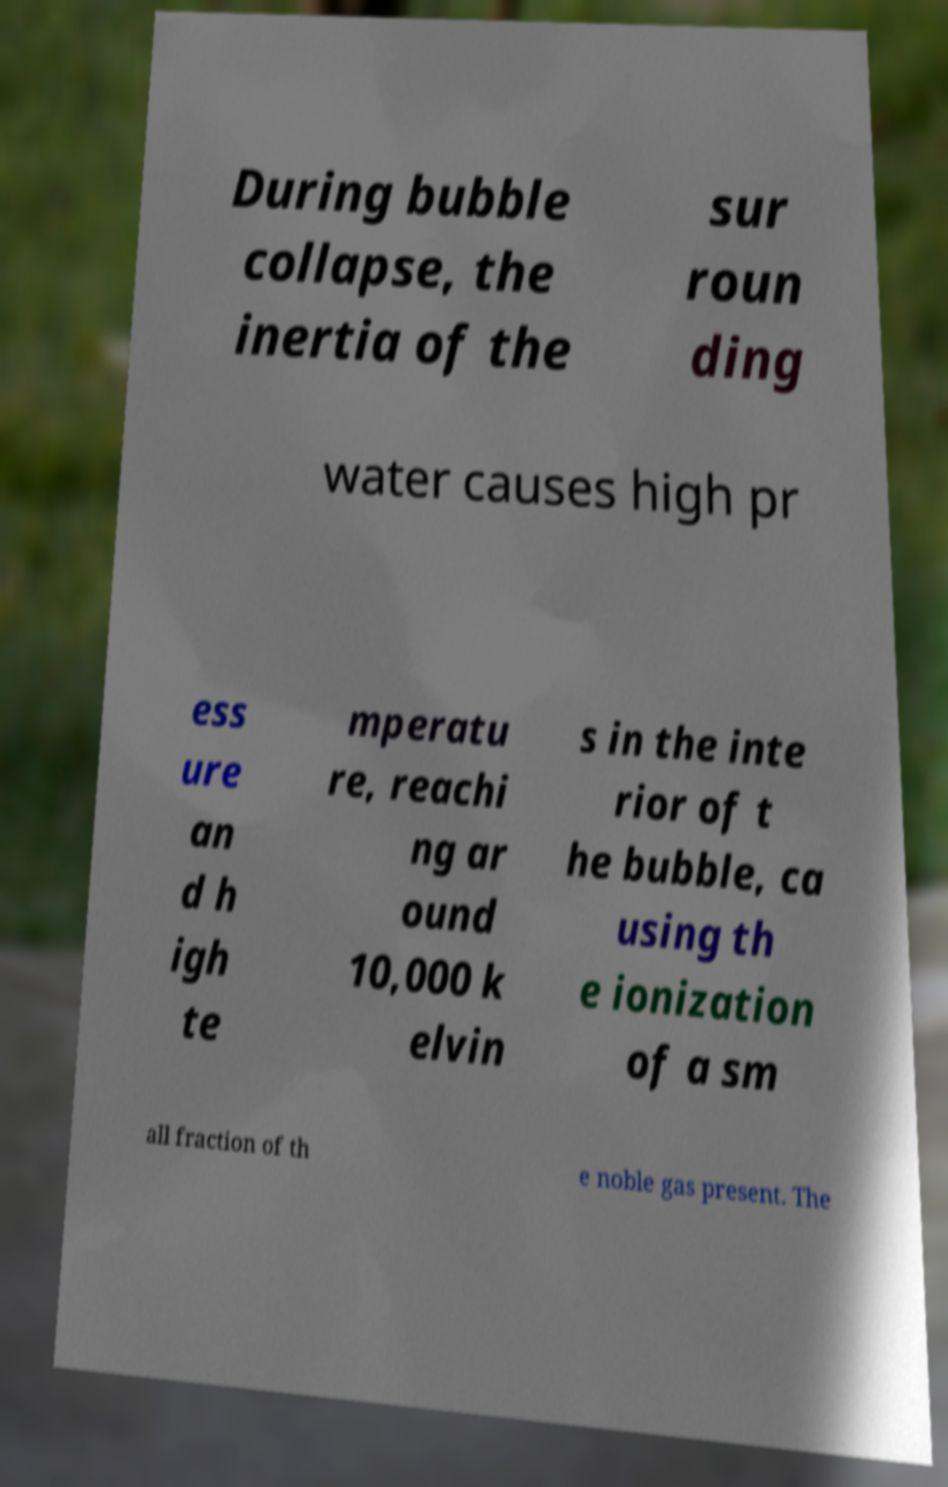Please read and relay the text visible in this image. What does it say? During bubble collapse, the inertia of the sur roun ding water causes high pr ess ure an d h igh te mperatu re, reachi ng ar ound 10,000 k elvin s in the inte rior of t he bubble, ca using th e ionization of a sm all fraction of th e noble gas present. The 